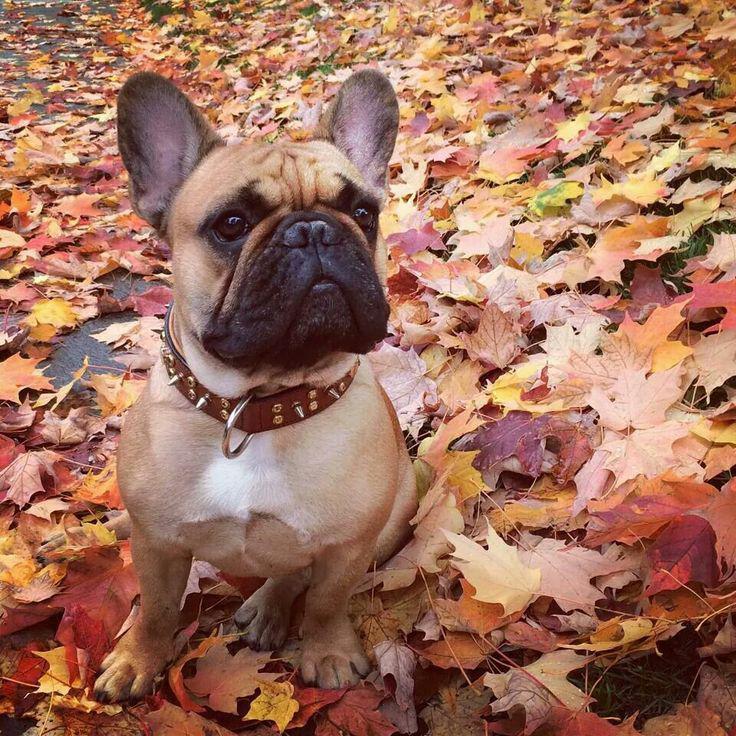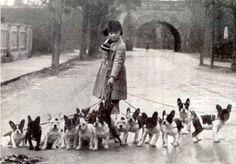The first image is the image on the left, the second image is the image on the right. For the images displayed, is the sentence "An image shows exactly one dog, which is sitting." factually correct? Answer yes or no. Yes. 